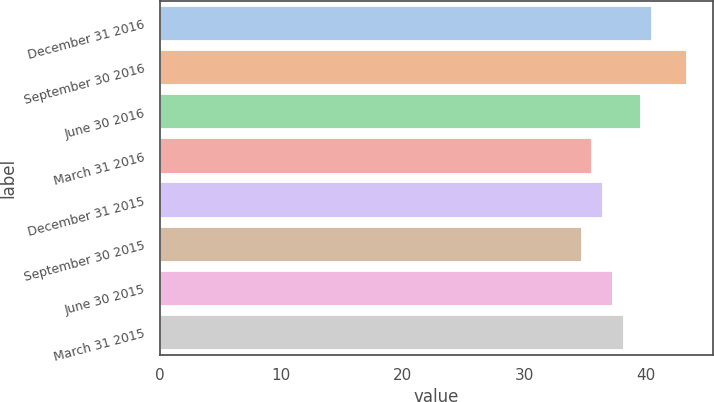<chart> <loc_0><loc_0><loc_500><loc_500><bar_chart><fcel>December 31 2016<fcel>September 30 2016<fcel>June 30 2016<fcel>March 31 2016<fcel>December 31 2015<fcel>September 30 2015<fcel>June 30 2015<fcel>March 31 2015<nl><fcel>40.43<fcel>43.3<fcel>39.57<fcel>35.57<fcel>36.43<fcel>34.71<fcel>37.29<fcel>38.15<nl></chart> 